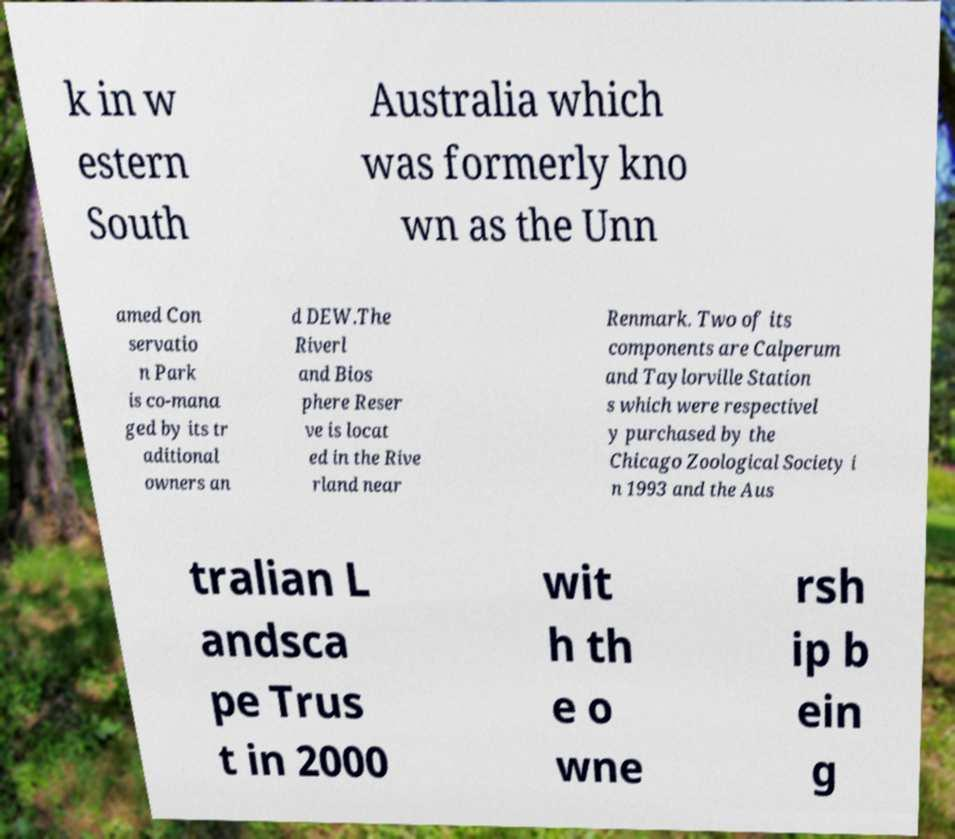Can you read and provide the text displayed in the image?This photo seems to have some interesting text. Can you extract and type it out for me? k in w estern South Australia which was formerly kno wn as the Unn amed Con servatio n Park is co-mana ged by its tr aditional owners an d DEW.The Riverl and Bios phere Reser ve is locat ed in the Rive rland near Renmark. Two of its components are Calperum and Taylorville Station s which were respectivel y purchased by the Chicago Zoological Society i n 1993 and the Aus tralian L andsca pe Trus t in 2000 wit h th e o wne rsh ip b ein g 